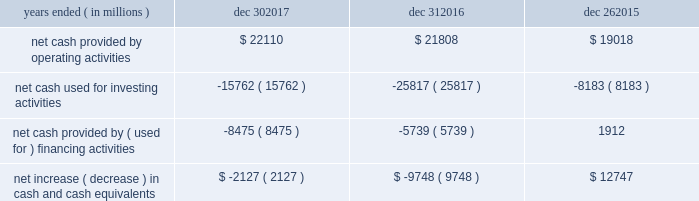In summary , our cash flows for each period were as follows : years ended ( in millions ) dec 30 , dec 31 , dec 26 .
Operating activities cash provided by operating activities is net income adjusted for certain non-cash items and changes in assets and liabilities .
For 2017 compared to 2016 , the $ 302 million increase in cash provided by operating activities was due to changes to working capital partially offset by adjustments for non-cash items and lower net income .
Tax reform did not have an impact on our 2017 cash provided by operating activities .
The increase in cash provided by operating activities was driven by increased income before taxes and $ 1.0 billion receipts of customer deposits .
These increases were partially offset by increased inventory and accounts receivable .
Income taxes paid , net of refunds , in 2017 compared to 2016 were $ 2.9 billion higher due to higher income before taxes , taxable gains on sales of asml , and taxes on the isecg divestiture .
We expect approximately $ 2.0 billion of additional customer deposits in 2018 .
For 2016 compared to 2015 , the $ 2.8 billion increase in cash provided by operating activities was due to adjustments for non-cash items and changes in working capital , partially offset by lower net income .
The adjustments for non-cash items were higher in 2016 primarily due to restructuring and other charges and the change in deferred taxes , partially offset by lower depreciation .
Investing activities investing cash flows consist primarily of capital expenditures ; investment purchases , sales , maturities , and disposals ; and proceeds from divestitures and cash used for acquisitions .
Our capital expenditures were $ 11.8 billion in 2017 ( $ 9.6 billion in 2016 and $ 7.3 billion in 2015 ) .
The decrease in cash used for investing activities in 2017 compared to 2016 was primarily due to higher net activity of available-for sale-investments in 2017 , proceeds from our divestiture of isecg in 2017 , and higher maturities and sales of trading assets in 2017 .
This activity was partially offset by higher capital expenditures in 2017 .
The increase in cash used for investing activities in 2016 compared to 2015 was primarily due to our completed acquisition of altera , net purchases of trading assets in 2016 compared to net sales of trading assets in 2015 , and higher capital expenditures in 2016 .
This increase was partially offset by lower investments in non-marketable equity investments .
Financing activities financing cash flows consist primarily of repurchases of common stock , payment of dividends to stockholders , issuance and repayment of short-term and long-term debt , and proceeds from the sale of shares of common stock through employee equity incentive plans .
The increase in cash used for financing activities in 2017 compared to 2016 was primarily due to net long-term debt activity , which was a use of cash in 2017 compared to a source of cash in 2016 .
During 2017 , we repurchased $ 3.6 billion of common stock under our authorized common stock repurchase program , compared to $ 2.6 billion in 2016 .
As of december 30 , 2017 , $ 13.2 billion remained available for repurchasing common stock under the existing repurchase authorization limit .
We base our level of common stock repurchases on internal cash management decisions , and this level may fluctuate .
Proceeds from the sale of common stock through employee equity incentive plans totaled $ 770 million in 2017 compared to $ 1.1 billion in 2016 .
Our total dividend payments were $ 5.1 billion in 2017 compared to $ 4.9 billion in 2016 .
We have paid a cash dividend in each of the past 101 quarters .
In january 2018 , our board of directors approved an increase to our cash dividend to $ 1.20 per share on an annual basis .
The board has declared a quarterly cash dividend of $ 0.30 per share of common stock for q1 2018 .
The dividend is payable on march 1 , 2018 to stockholders of record on february 7 , 2018 .
Cash was used for financing activities in 2016 compared to cash provided by financing activities in 2015 , primarily due to fewer debt issuances and the repayment of debt in 2016 .
This activity was partially offset by repayment of commercial paper in 2015 and fewer common stock repurchases in 2016 .
Md&a - results of operations consolidated results and analysis 37 .
As of december 31 2017 what was percent of the net cash used for investing activities to the net cash provided by operating activities? 
Rationale: as of december 31 2017 71.3% of the net cash provided by operating activities was used for net cash used for investing activities
Computations: (15762 / 22110)
Answer: 0.71289. 